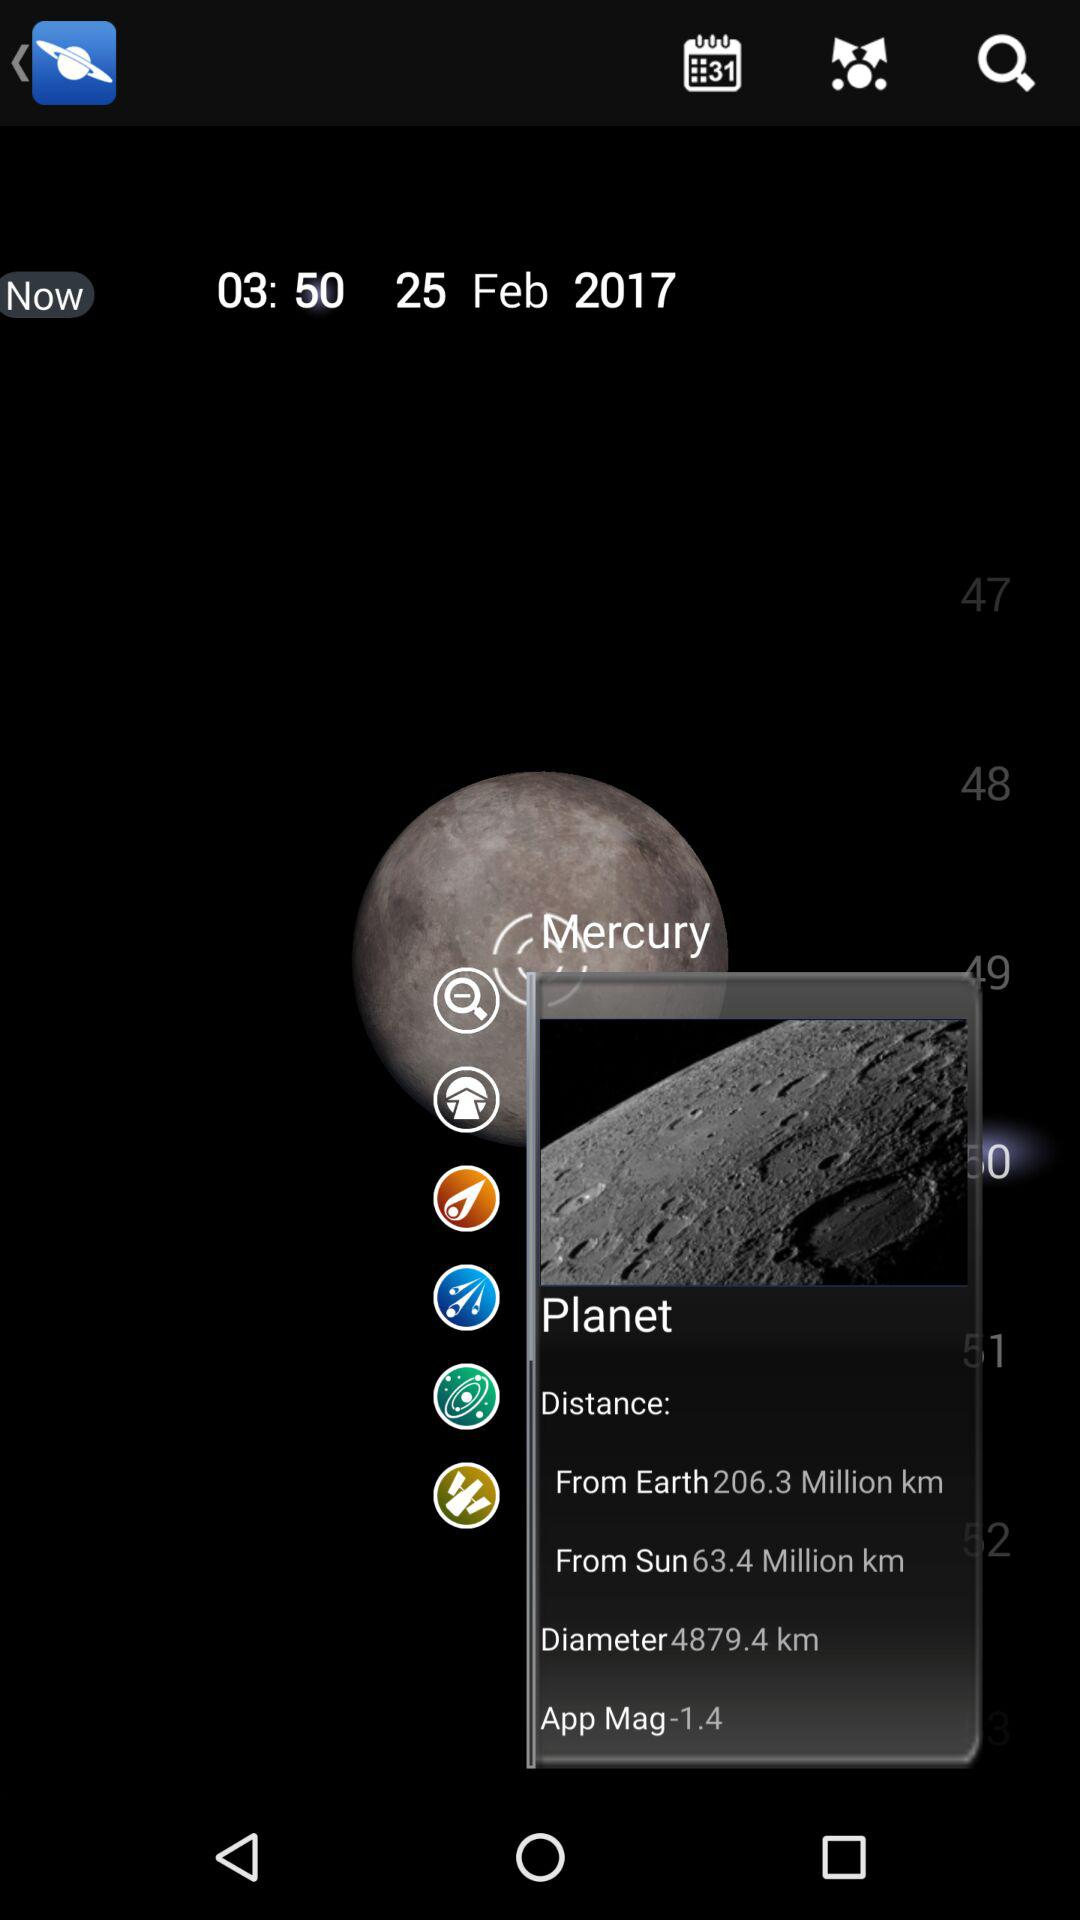What date is shown on the application? The date shown on the application is February 25, 2017. 